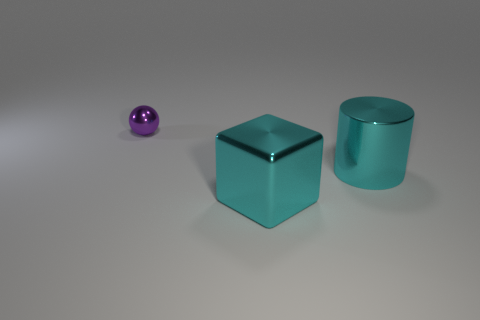There is a cyan cylinder that is the same size as the block; what is its material?
Keep it short and to the point. Metal. There is a purple object that is to the left of the big metal block; does it have the same shape as the cyan shiny object on the left side of the big cylinder?
Provide a succinct answer. No. There is a cyan thing that is the same size as the cyan block; what shape is it?
Your answer should be compact. Cylinder. Do the object that is in front of the cyan cylinder and the large object behind the metal block have the same material?
Your answer should be very brief. Yes. There is a object that is in front of the cyan cylinder; are there any cyan metallic blocks on the right side of it?
Your answer should be compact. No. What color is the cube that is the same material as the tiny thing?
Provide a succinct answer. Cyan. Are there more large cyan blocks than yellow cylinders?
Your answer should be very brief. Yes. What number of things are either objects that are left of the cylinder or small metallic spheres?
Your response must be concise. 2. Are there any cyan metal cylinders that have the same size as the metallic ball?
Your answer should be very brief. No. Are there fewer shiny things than cyan objects?
Keep it short and to the point. No. 